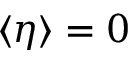<formula> <loc_0><loc_0><loc_500><loc_500>\langle \eta \rangle = 0</formula> 